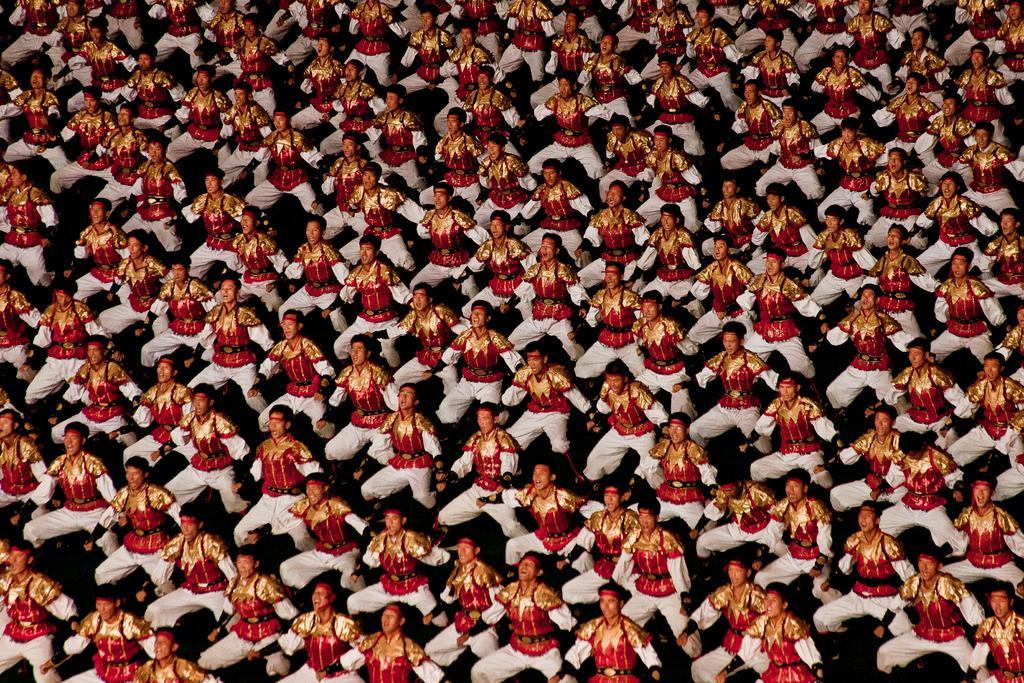Describe this image in one or two sentences. In this picture I can see many men who are wearing the same dress. They are dancing. 